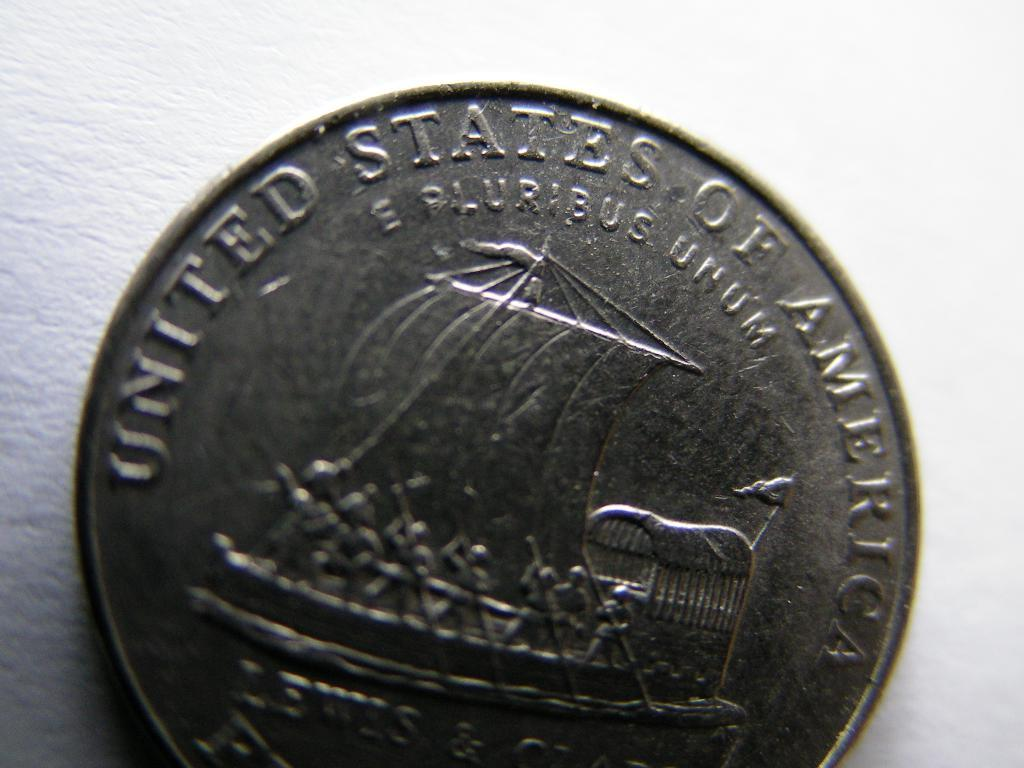Provide a one-sentence caption for the provided image. A coin reads, "The United States of America" across the top. 